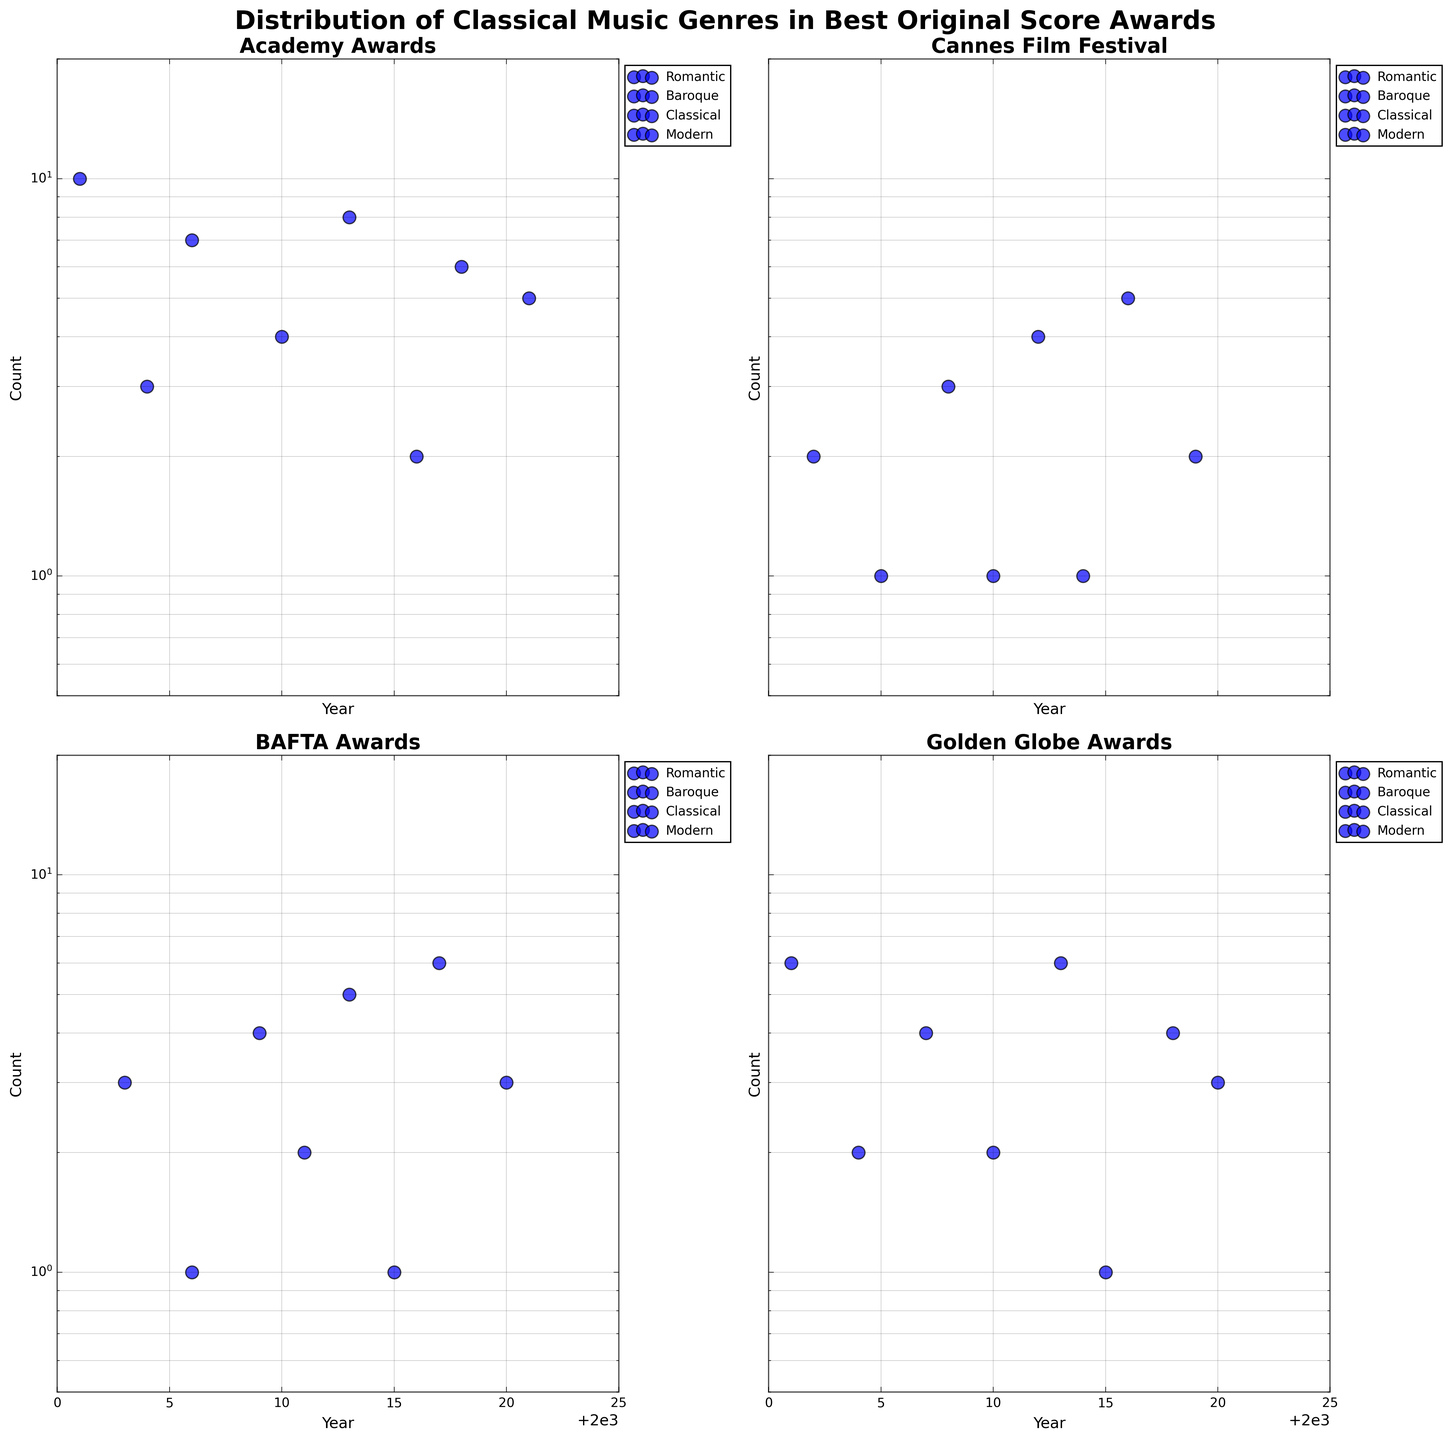what is the title of the plot? The title should be printed at the top of the plot in large, bold text.
Answer: Distribution of Classical Music Genres in Best Original Score Awards What are the classical music genres shown in the plot? To find this, look at the legend in any of the subplots, as the genres will be listed there.
Answer: Romantic, Baroque, Classical, Modern How many times was the Romantic genre awarded in the Academy Awards in 2013? Locate the Academy Awards subplot, find the year 2013, and look at the count for Romantic.
Answer: 8 Which festival has the highest count of Classical music awards in any single year? Look at the scatter points for the Classical genre in all subplots and find the highest count.
Answer: Academy Awards In which years did the Baroque genre receive awards in the Cannes Film Festival? Look at the scatter points for the Baroque genre in the Cannes Film Festival subplot and note the years.
Answer: 2005, 2014 Compare the counts for Modern genre in the BAFTA Awards in 2011 and 2020. Which year had a higher count? Locate the BAFTA Awards subplot, find the counts for Modern in 2011 and 2020, and compare them.
Answer: 2020 What is the range of counts (minimum to maximum) shown in any subplot? Look at the y-axis log scale limits or scatter points in any subplot to determine the range.
Answer: 1 to 10 What are the common years across all festivals where Romantic genre was awarded? Identify the scatter points for Romantic across all subplots and check for common years.
Answer: None How many Classical music awards were given in total in the Golden Globe Awards festival? Sum up the counts for Classical music in the Golden Globe Awards subplot.
Answer: 12 In which year did each festival have the lowest count for the Modern genre? Identify the minimum count for the Modern genre in each subplot by looking at the smallest y-values.
Answer: Academy Awards: 2010, Cannes Film Festival: 2010, BAFTA Awards: 2011, Golden Globe Awards: 2001 